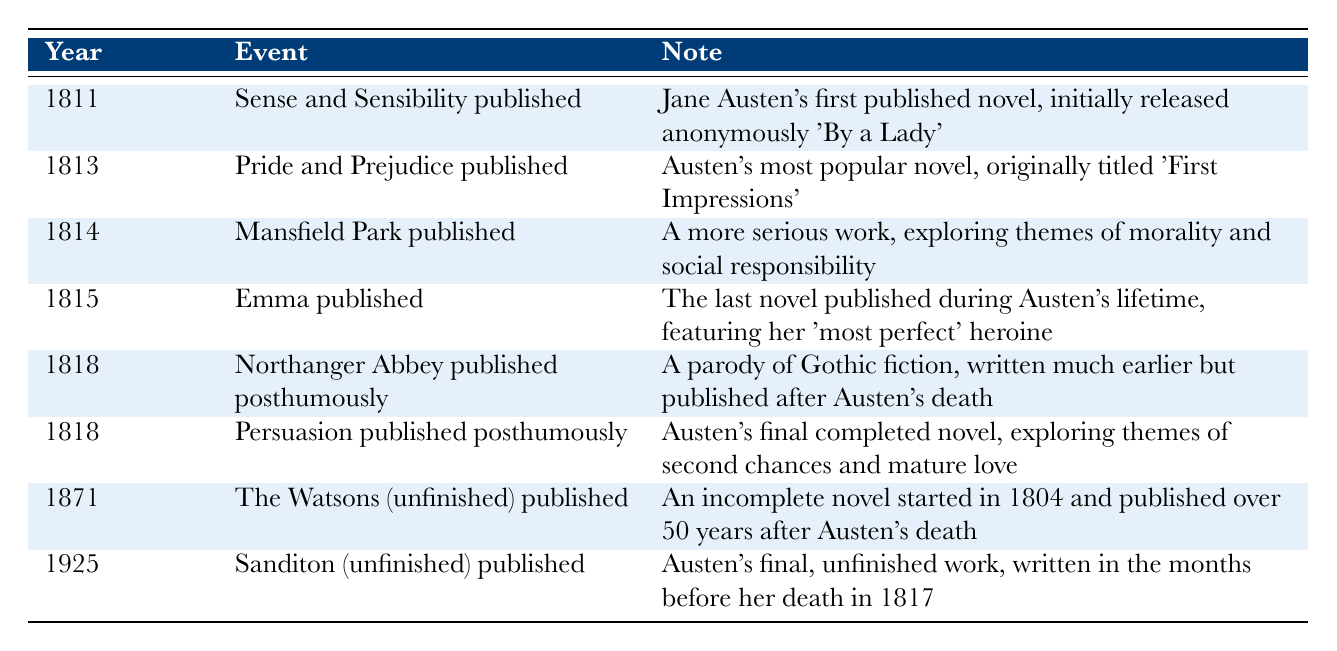What year was "Pride and Prejudice" published? According to the table, "Pride and Prejudice" was published in the year 1813.
Answer: 1813 Which novel published in 1818 is a parody of Gothic fiction? The table shows that "Northanger Abbey," published in 1818, is a parody of Gothic fiction.
Answer: Northanger Abbey How many years after "Sense and Sensibility" was "Emma" published? "Sense and Sensibility" was published in 1811, and "Emma" was published in 1815. The difference is 1815 - 1811 = 4 years.
Answer: 4 years Is "The Watsons" an unfinished novel? The note in the table specifies that "The Watsons" is an unfinished novel published in 1871.
Answer: Yes Which novel, published posthumously, was Austen's final completed work? The table indicates that "Persuasion," published posthumously in 1818, is Austen's final completed novel, as noted in the same row.
Answer: Persuasion Of the novels listed, how many were published during Jane Austen's lifetime? The table lists four novels published during Austen's lifetime: "Sense and Sensibility" (1811), "Pride and Prejudice" (1813), "Mansfield Park" (1814), and "Emma" (1815). Thus, the count is 4.
Answer: 4 In what chronological order were "Mansfield Park" and "Emma" published? "Mansfield Park" was published in 1814, followed by "Emma," which was published in 1815. Therefore, the order is Mansfield Park first, then Emma.
Answer: Mansfield Park, then Emma What was the title originally given to "Pride and Prejudice"? The table reveals that "Pride and Prejudice" was originally titled "First Impressions."
Answer: First Impressions 